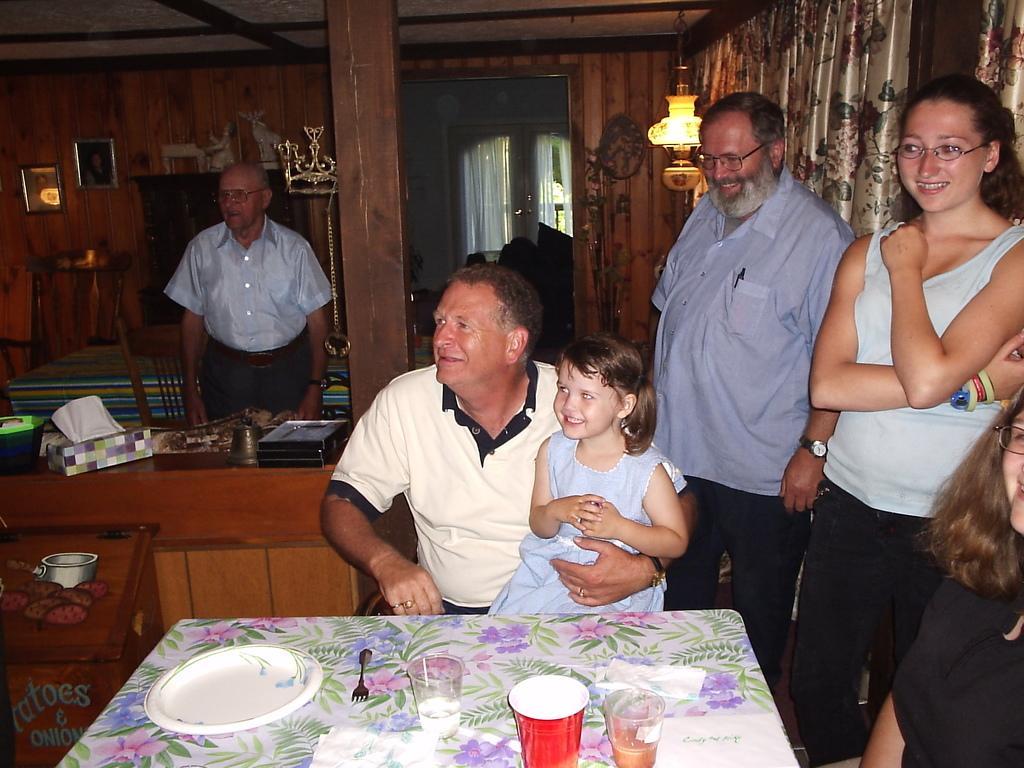Could you give a brief overview of what you see in this image? This picture is clicked inside the room. In the center we can see a person wearing white color t-shirt and sitting and we can see a girl wearing blue color frock, smiling and sitting on the lap of a person. In the foreground we can see a table on the top of which a white color platter, fork, glass of water, glass of drink and a red color glass and some papers are placed. On the right corner we can a person wearing black color t-shirt and seems to be sitting and we can see a woman wearing t-shirt, smiling and standing on the ground and we can see a man wearing blue color shirt, smiling and standing. On the left we can see there are some objects placed on the top of the wooden tables. In the background we can see a table, chairs, show pieces, picture frames hanging on the wall and we can see a person standing on the floor and we can see a wooden pillar and a chandelier hanging on the roof and we can see the curtains, window and many other objects. 